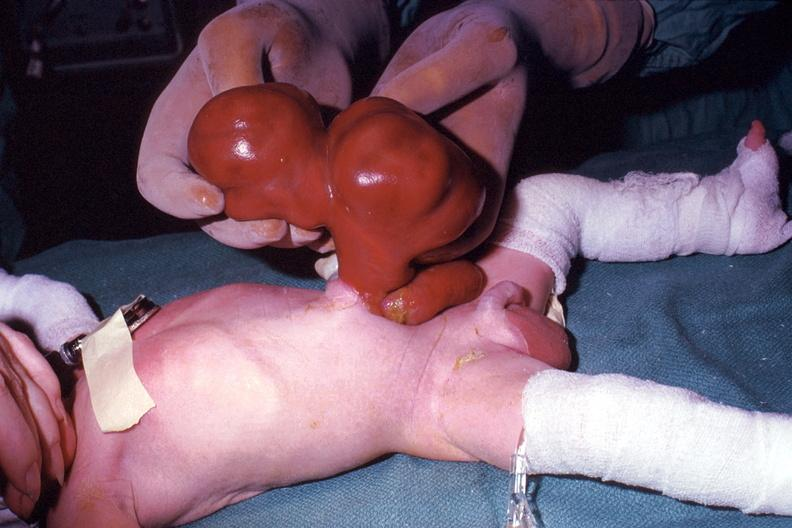s omphalocele present?
Answer the question using a single word or phrase. Yes 